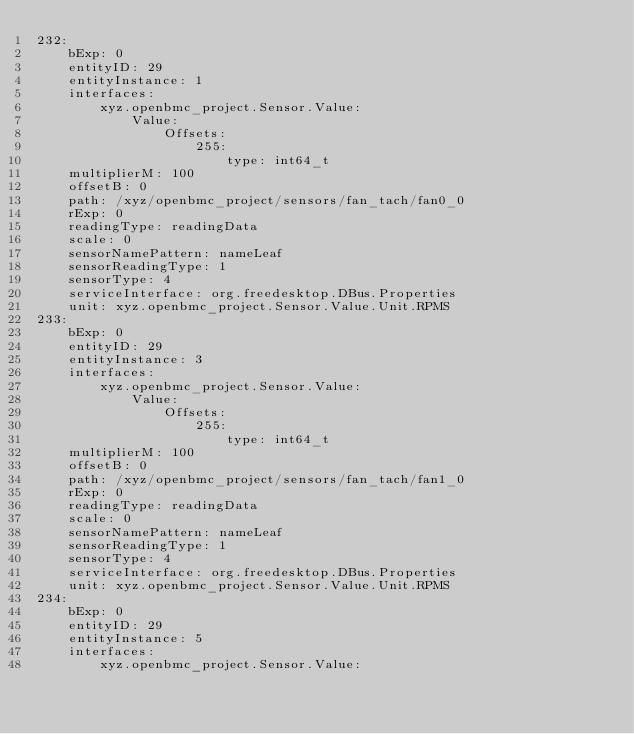<code> <loc_0><loc_0><loc_500><loc_500><_YAML_>232:
    bExp: 0
    entityID: 29
    entityInstance: 1
    interfaces:
        xyz.openbmc_project.Sensor.Value:
            Value:
                Offsets:
                    255:
                        type: int64_t
    multiplierM: 100
    offsetB: 0
    path: /xyz/openbmc_project/sensors/fan_tach/fan0_0
    rExp: 0
    readingType: readingData
    scale: 0
    sensorNamePattern: nameLeaf
    sensorReadingType: 1
    sensorType: 4
    serviceInterface: org.freedesktop.DBus.Properties
    unit: xyz.openbmc_project.Sensor.Value.Unit.RPMS
233:
    bExp: 0
    entityID: 29
    entityInstance: 3
    interfaces:
        xyz.openbmc_project.Sensor.Value:
            Value:
                Offsets:
                    255:
                        type: int64_t
    multiplierM: 100
    offsetB: 0
    path: /xyz/openbmc_project/sensors/fan_tach/fan1_0
    rExp: 0
    readingType: readingData
    scale: 0
    sensorNamePattern: nameLeaf
    sensorReadingType: 1
    sensorType: 4
    serviceInterface: org.freedesktop.DBus.Properties
    unit: xyz.openbmc_project.Sensor.Value.Unit.RPMS
234:
    bExp: 0
    entityID: 29
    entityInstance: 5
    interfaces:
        xyz.openbmc_project.Sensor.Value:</code> 